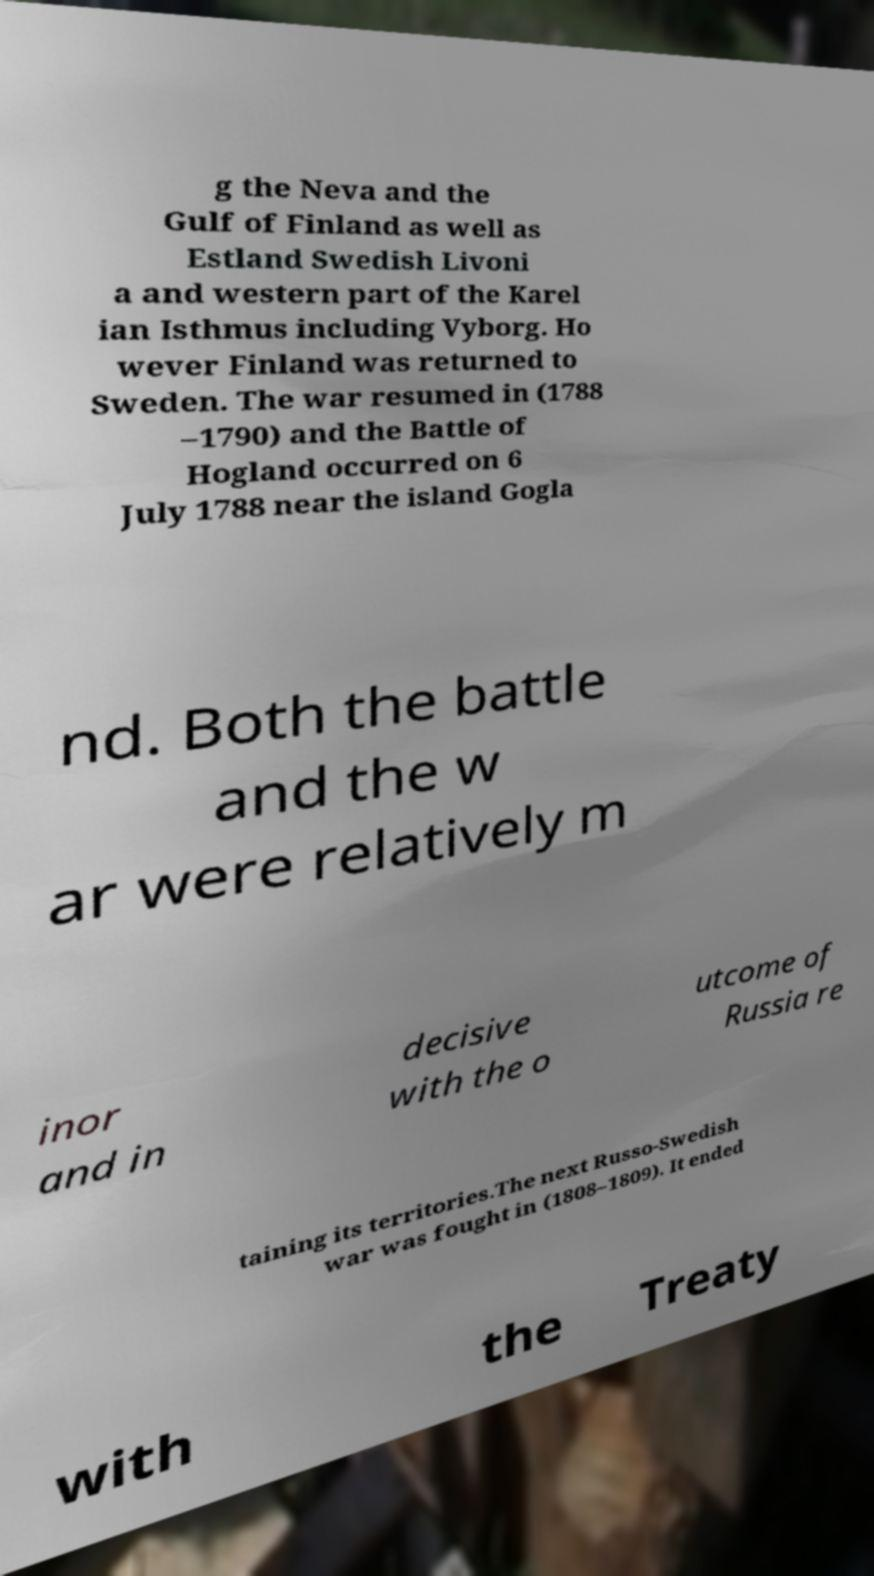Could you assist in decoding the text presented in this image and type it out clearly? g the Neva and the Gulf of Finland as well as Estland Swedish Livoni a and western part of the Karel ian Isthmus including Vyborg. Ho wever Finland was returned to Sweden. The war resumed in (1788 –1790) and the Battle of Hogland occurred on 6 July 1788 near the island Gogla nd. Both the battle and the w ar were relatively m inor and in decisive with the o utcome of Russia re taining its territories.The next Russo-Swedish war was fought in (1808–1809). It ended with the Treaty 